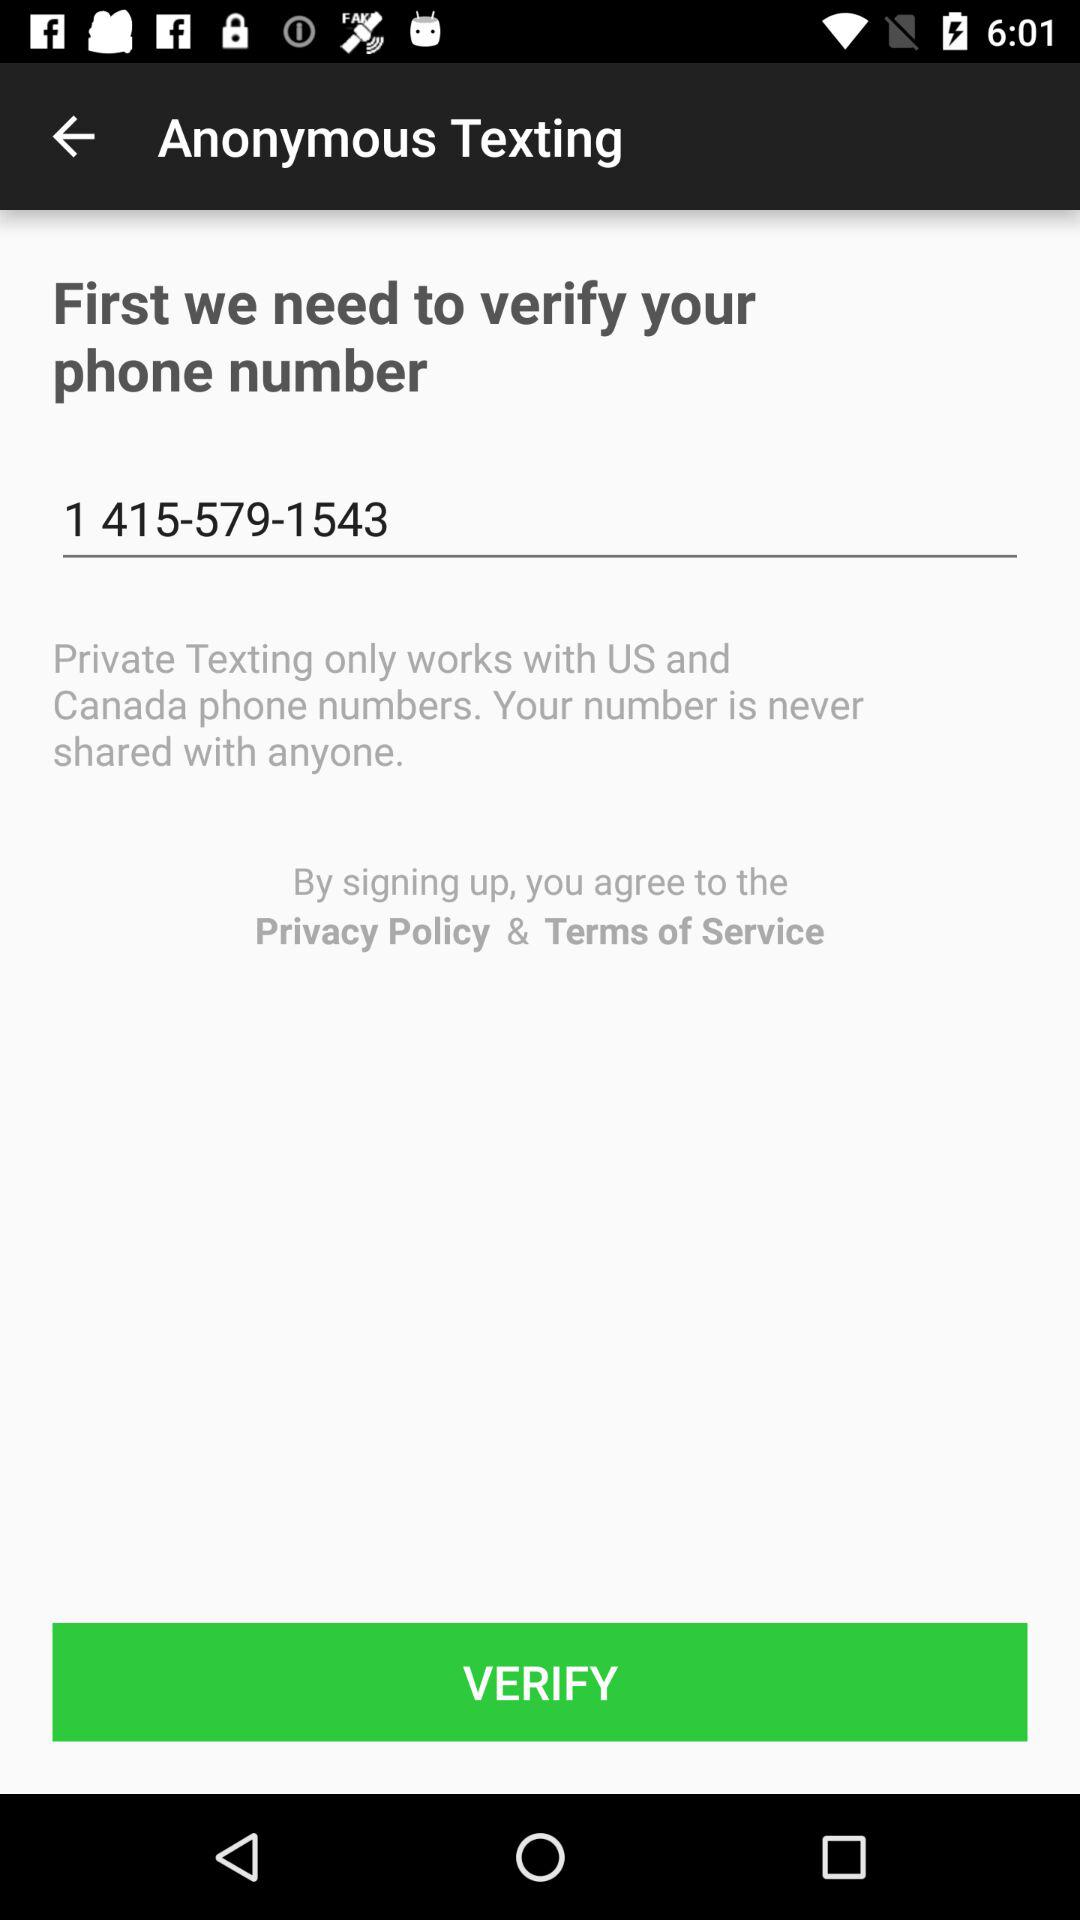Private texting is available in which countries? Private texting is available in the US and Canada. 